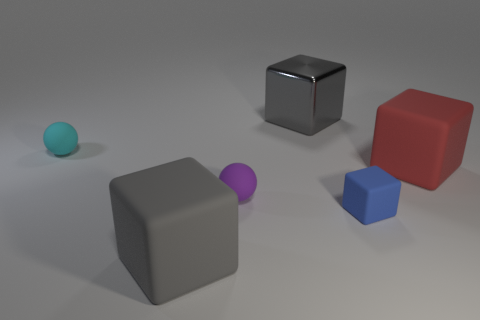How many gray things are in front of the red thing and behind the cyan object?
Offer a terse response. 0. There is a gray matte object that is the same size as the red matte cube; what shape is it?
Ensure brevity in your answer.  Cube. Is the small blue cube left of the red rubber thing made of the same material as the block behind the tiny cyan ball?
Offer a terse response. No. How many big brown blocks are there?
Make the answer very short. 0. How many cyan objects are the same shape as the purple thing?
Provide a short and direct response. 1. Do the purple thing and the small cyan matte thing have the same shape?
Ensure brevity in your answer.  Yes. What is the size of the blue object?
Provide a short and direct response. Small. How many metal cubes are the same size as the purple sphere?
Make the answer very short. 0. Is the size of the sphere that is behind the tiny purple rubber ball the same as the rubber cube to the left of the small purple thing?
Ensure brevity in your answer.  No. There is a big thing that is behind the big red block; what shape is it?
Provide a succinct answer. Cube. 